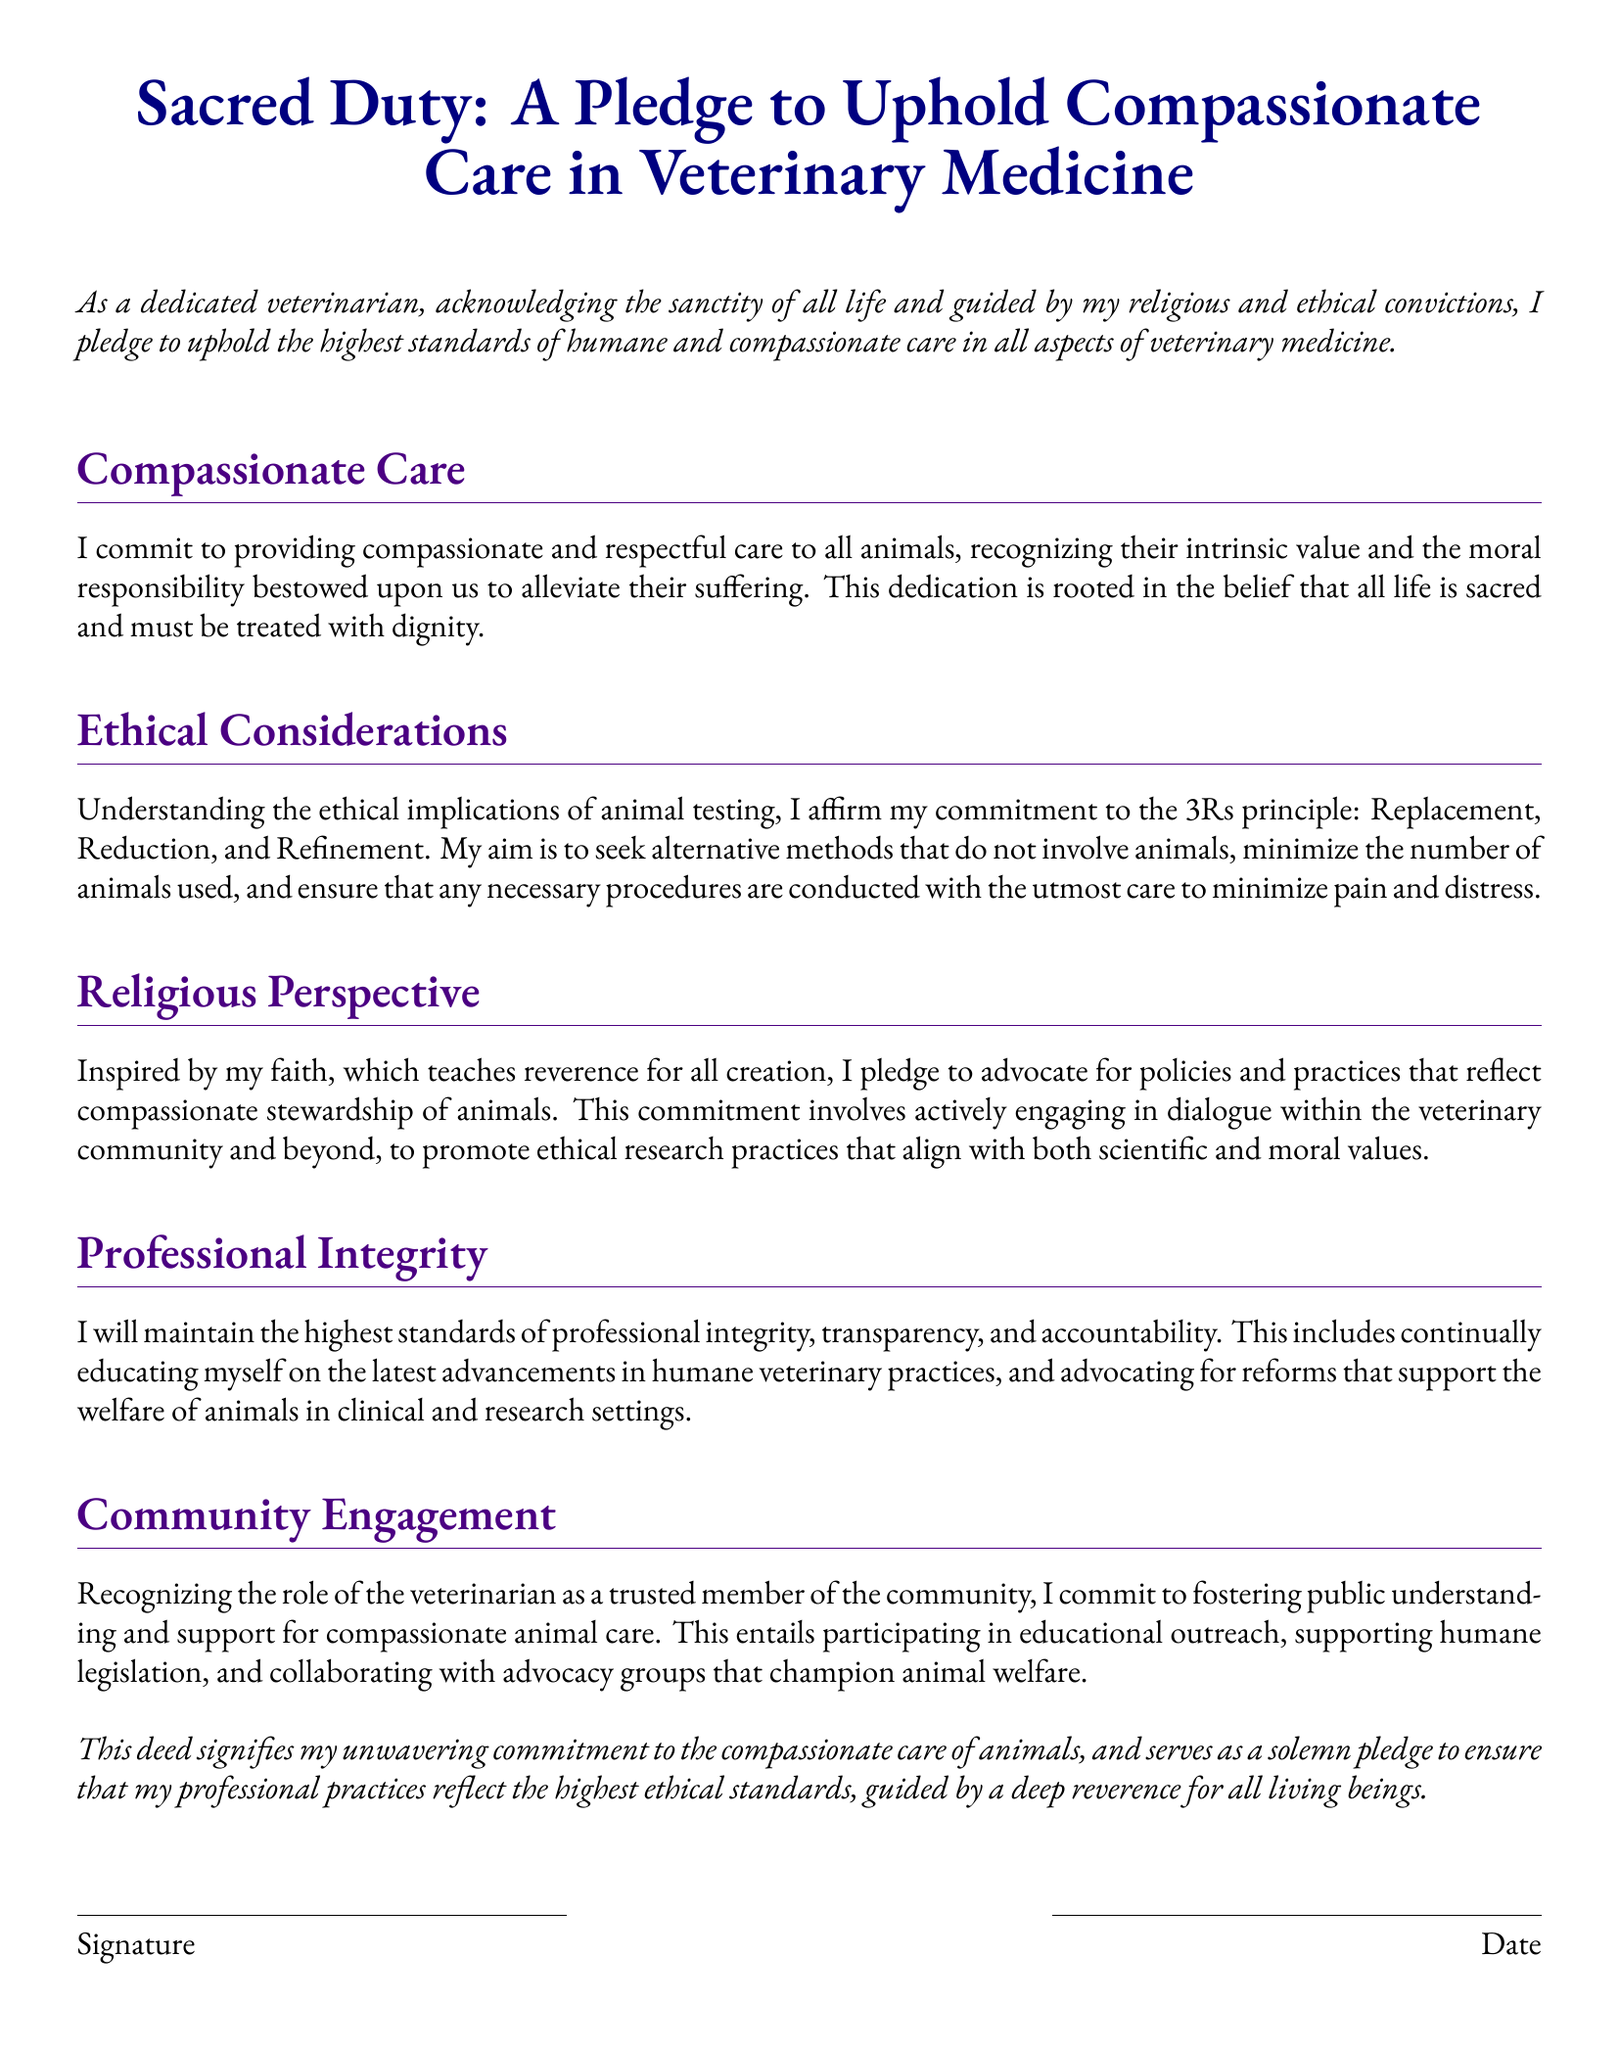What is the title of the document? The title of the document is the main heading provided at the beginning, which identifies its purpose.
Answer: Sacred Duty: A Pledge to Uphold Compassionate Care in Veterinary Medicine What principle does the document affirm regarding animal testing? The document specifies a commitment to the 3Rs principle concerning animal testing, which defines its ethical stance.
Answer: Replacement, Reduction, and Refinement Which type of care does the pledge promote? The document emphasizes a specific approach towards animal care that reflects the author's values and commitments.
Answer: Compassionate care What does the author commit to in terms of community involvement? The document outlines a specific role for the veterinarian in engaging with the public regarding animal welfare.
Answer: Fostering public understanding and support for compassionate animal care What is the main theme expressed in the document's introduction? The introduction highlights the author's core belief which guides their professional practice in veterinary medicine.
Answer: The sanctity of all life How does the document define the veterinarian's responsibility? The document outlines a moral and ethical duty associated with the care provided to animals.
Answer: Alleviate their suffering What are the two components listed at the end of the document? The end portion of the document includes specific sections related to the formal acknowledgment of the pledge by the individual.
Answer: Signature and Date 